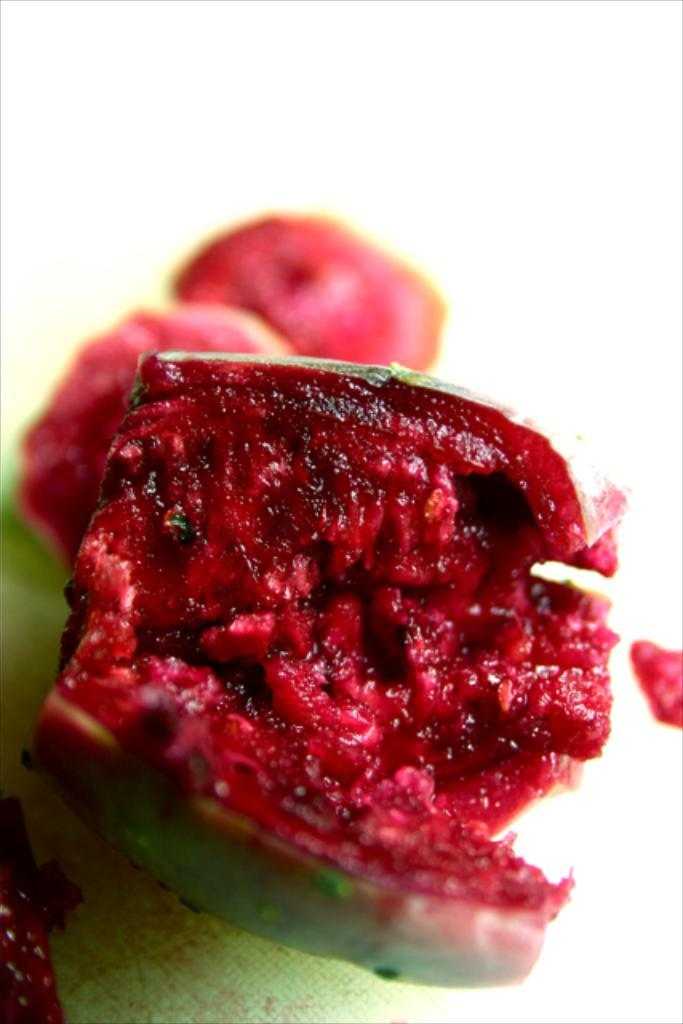What colors are present in the objects in the image? There are green and red color things in the image. What is the color of the background in the image? The background of the image is white. What type of trade is being conducted in the image? There is no indication of any trade being conducted in the image. What kind of trousers are the people wearing in the image? There are no people or trousers present in the image. 